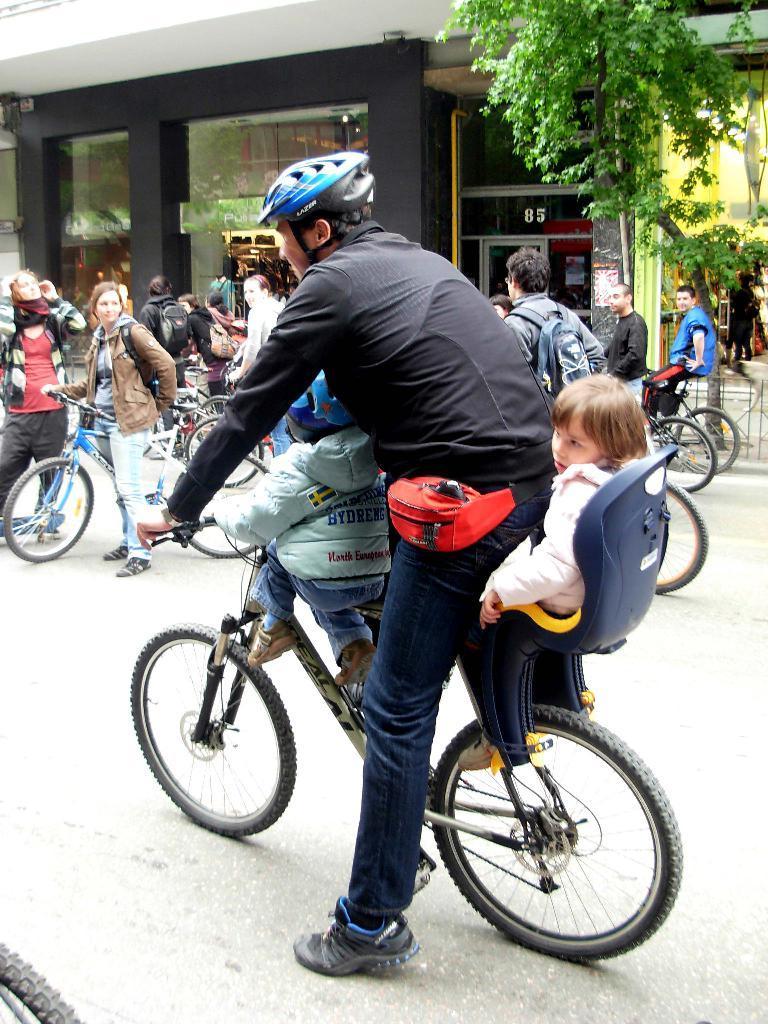Please provide a concise description of this image. There are so many people riding bicycle behind him there is a tree and building. 